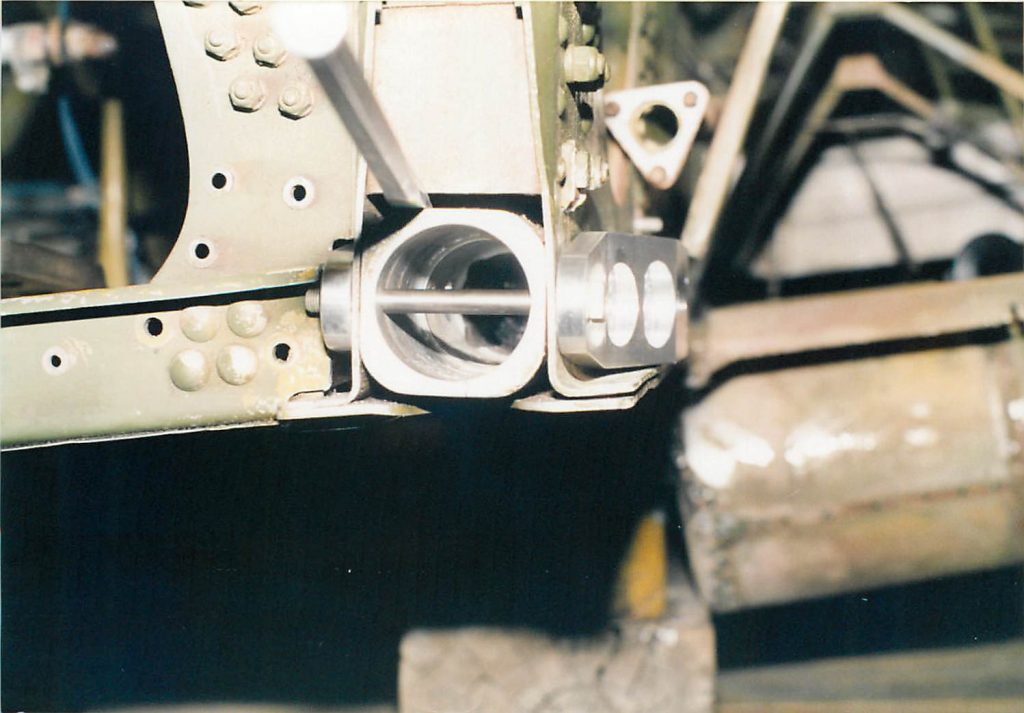What materials are typically used for making such cylindrical pins, and why? Materials like stainless steel or titanium are typically used for making cylindrical pins due to their strength, corrosion resistance, and fatigue resistance. These properties are essential because the pins must withstand high pressures and repetitive mechanical stress without deforming or failing. 